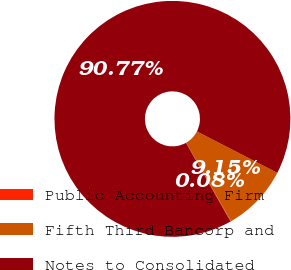<chart> <loc_0><loc_0><loc_500><loc_500><pie_chart><fcel>Public Accounting Firm<fcel>Fifth Third Bancorp and<fcel>Notes to Consolidated<nl><fcel>0.08%<fcel>9.15%<fcel>90.76%<nl></chart> 